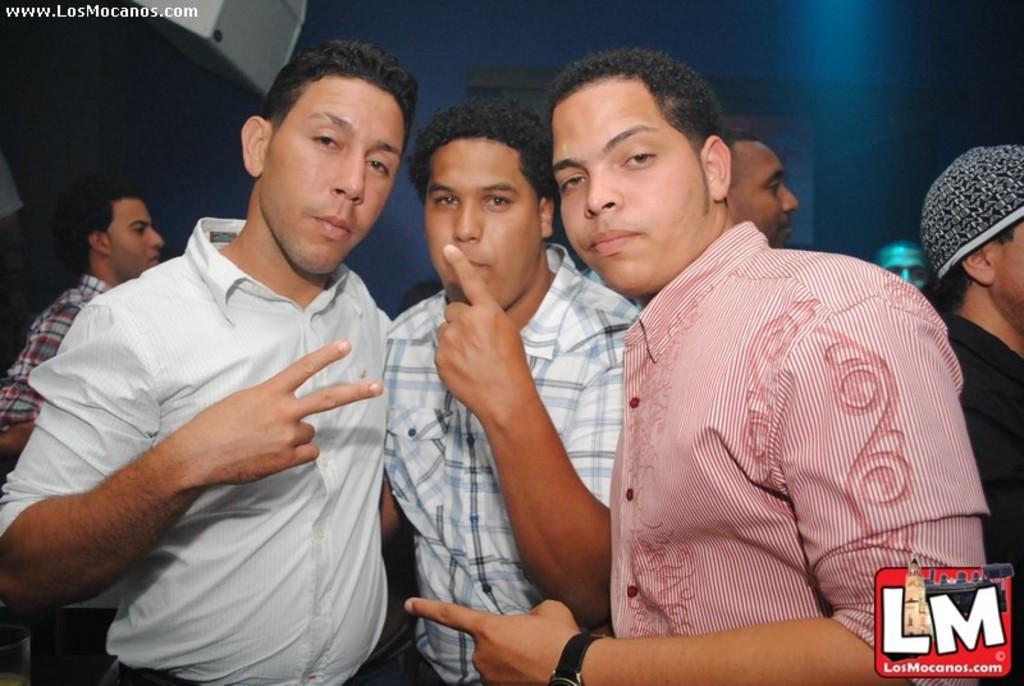In one or two sentences, can you explain what this image depicts? Here we can see three men standing. In the background we can see few persons,wall,screen and an object on the left side at the top. 